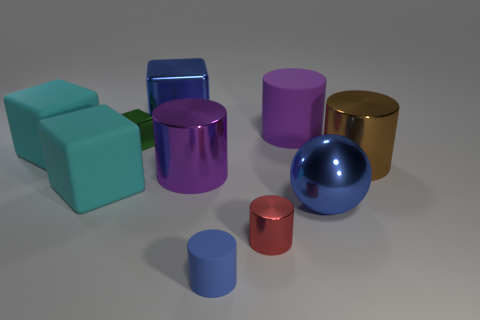What number of red objects are either tiny matte things or matte blocks? Analyzing the image, there is one small, matte red cylinder, which meets the criteria of being a tiny matte object. Therefore, the number of red objects that are either tiny matte things or matte blocks is one. 